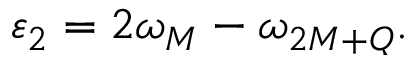Convert formula to latex. <formula><loc_0><loc_0><loc_500><loc_500>\varepsilon _ { 2 } = 2 \omega _ { M } - \omega _ { 2 M + Q } .</formula> 